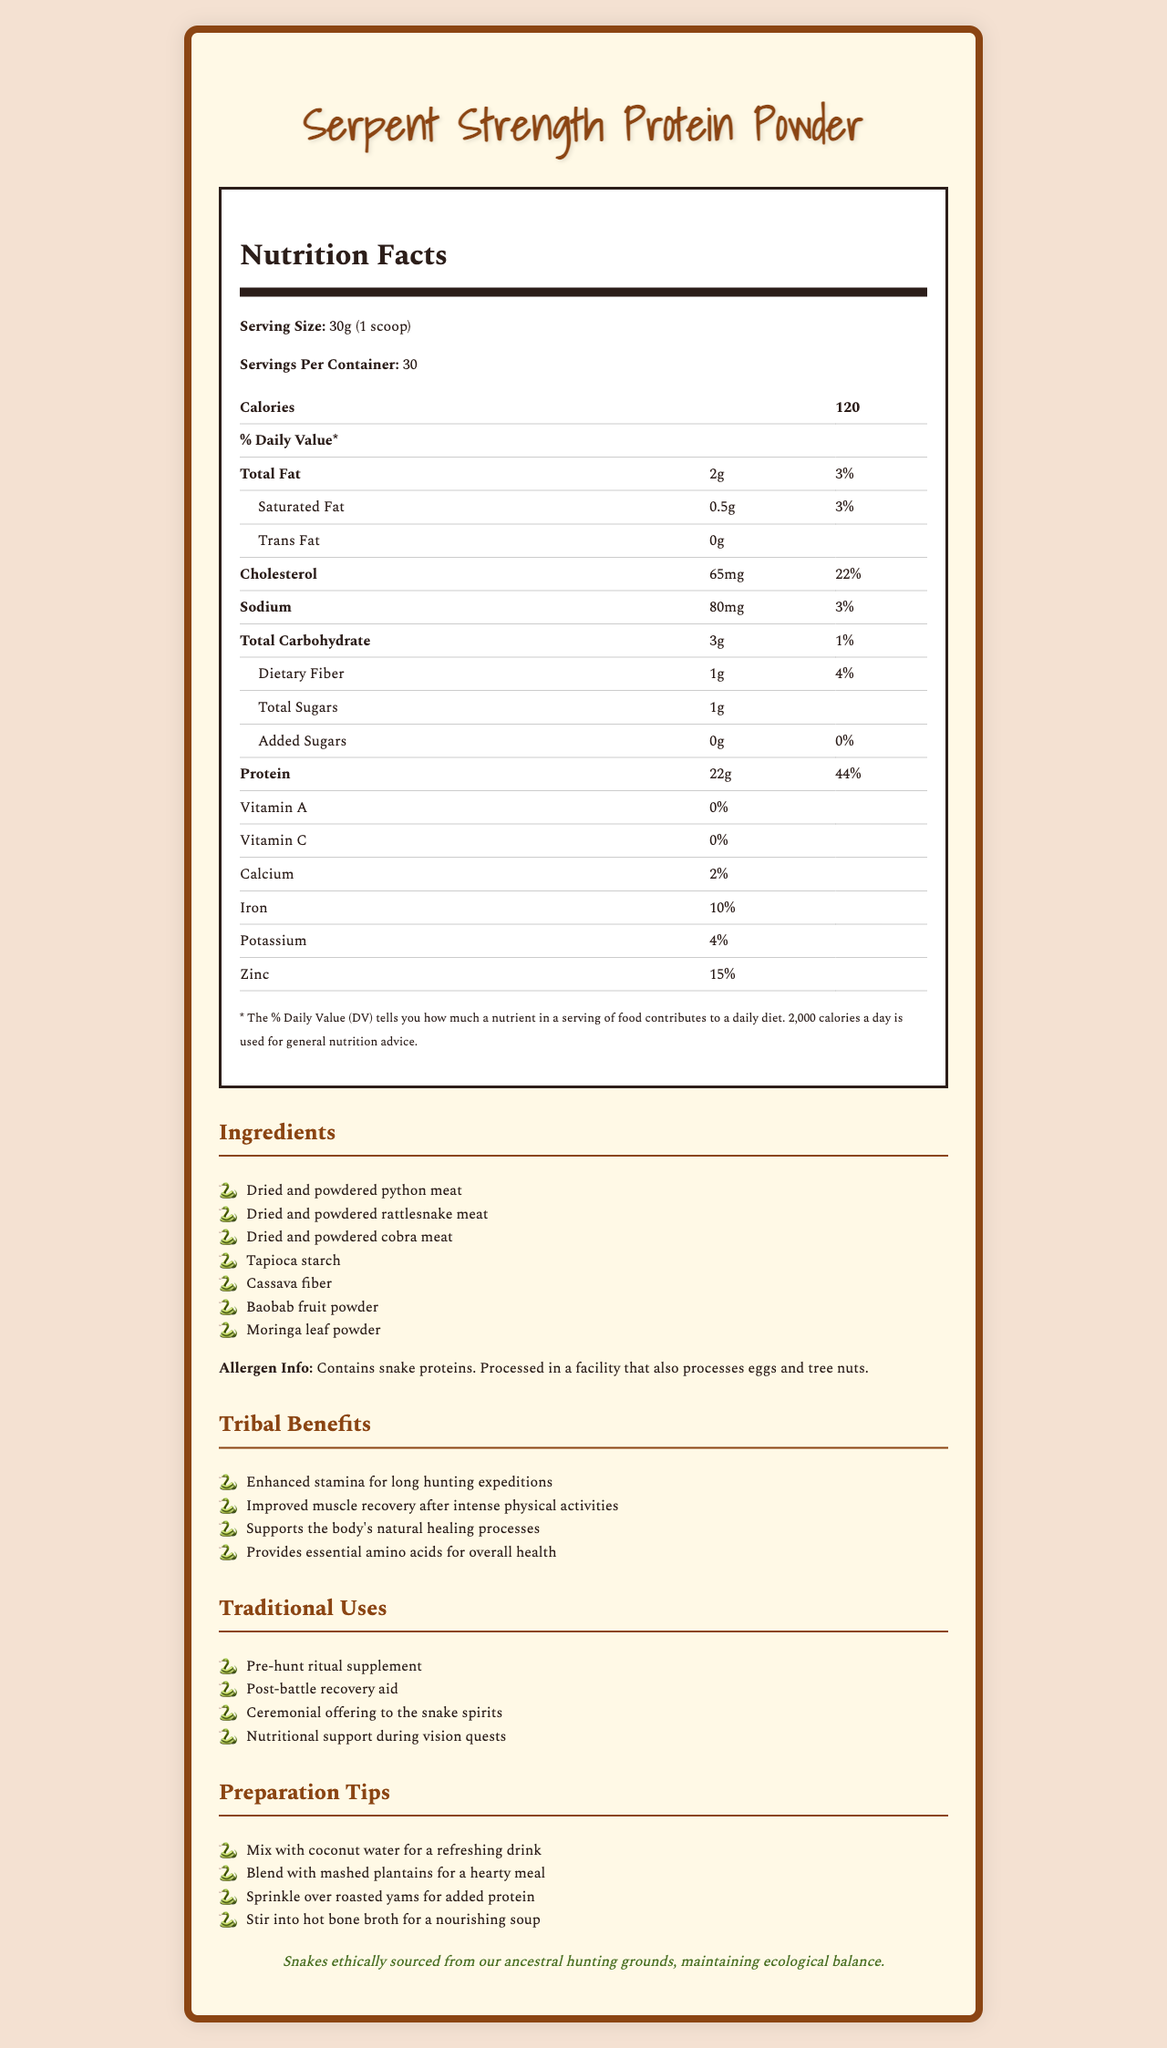what is the serving size of Serpent Strength Protein Powder? The serving size is explicitly mentioned at the beginning of the nutrition facts section.
Answer: 30g (1 scoop) how many servings are there per container? The document states there are 30 servings per container.
Answer: 30 how many calories does one serving of the protein powder contain? The nutrition label specifically lists 120 calories per serving.
Answer: 120 what is the total fat content in a single serving? The total fat content for one serving is listed as 2g in the nutrition facts.
Answer: 2g what is the main source of protein in the Serpent Strength Protein Powder? The ingredients list shows that dried and powdered python, rattlesnake, and cobra meat are the main sources of protein.
Answer: Dried and powdered snake meats what percentage of the daily value of iron does one serving contain? The nutrition facts indicate that one serving contains 10% of the daily value of iron.
Answer: 10% how much protein is in one serving of Serpent Strength Protein Powder? A. 10g B. 22g C. 30g The protein content listed per serving is 22g.
Answer: B. 22g which of the following traditional uses is mentioned for this protein powder? I. Pre-hunt ritual supplement II. Vision quest support III. Modern gym supplementation The traditional uses section lists pre-hunt ritual supplement and vision quest support among others. Modern gym supplementation is not mentioned.
Answer: I, II are there any sugars added to this protein powder? The document specifies that there are 0g of added sugars.
Answer: No does this product contain allergens? It contains snake proteins and is processed in a facility that also processes eggs and tree nuts, as indicated in the allergen info section.
Answer: Yes summarize the main nutritional benefits of Serpent Strength Protein Powder. These benefits are described in the tribal benefits section of the document and reflect the main nutritional advantages of the product.
Answer: The Serpent Strength Protein Powder provides enhanced stamina, muscle recovery, supports natural healing processes, and provides essential amino acids. how do the preparation tips suggest using this protein powder? These preparation tips are detailed in the outlined list toward the end of the document.
Answer: Mix with coconut water, blend with mashed plantains, sprinkle over roasted yams, stir into hot bone broth. is the protein powder sustainably sourced? The document includes a sustainability note mentioning that snakes are ethically sourced from ancestral hunting grounds.
Answer: Yes what is the cholesterol content in one serving of the Serpent Strength Protein Powder? A. 22mg B. 30mg C. 65mg The nutrition facts list 65mg of cholesterol per serving.
Answer: C. 65mg does one serving provide any Vitamin A? The document states 0% daily value for Vitamin A per serving.
Answer: No what age group is the Serpent Strength Protein Powder primarily meant for? The document does not specify any age group for the protein powder.
Answer: Not enough information 